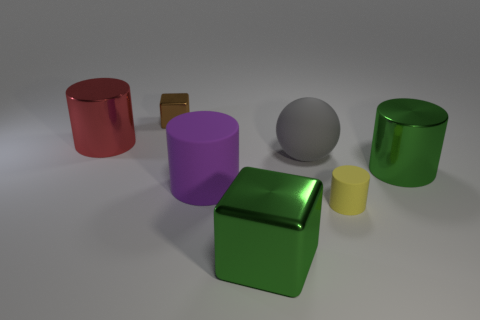There is a green metal object that is the same shape as the large red thing; what is its size?
Provide a short and direct response. Large. How many large spheres have the same material as the large purple object?
Offer a very short reply. 1. There is a shiny block in front of the large red cylinder; how many big matte spheres are on the right side of it?
Make the answer very short. 1. There is a large purple matte cylinder; are there any big green metallic cylinders in front of it?
Your response must be concise. No. Is the shape of the large green shiny object that is behind the yellow matte cylinder the same as  the large red thing?
Your answer should be compact. Yes. There is a object that is the same color as the big metal block; what is its material?
Offer a terse response. Metal. How many shiny objects are the same color as the big rubber ball?
Your answer should be compact. 0. What shape is the small object that is in front of the big metal thing that is to the left of the brown metallic thing?
Ensure brevity in your answer.  Cylinder. Is there another shiny object of the same shape as the brown object?
Make the answer very short. Yes. Do the big cube and the large metallic cylinder that is right of the big red cylinder have the same color?
Make the answer very short. Yes. 